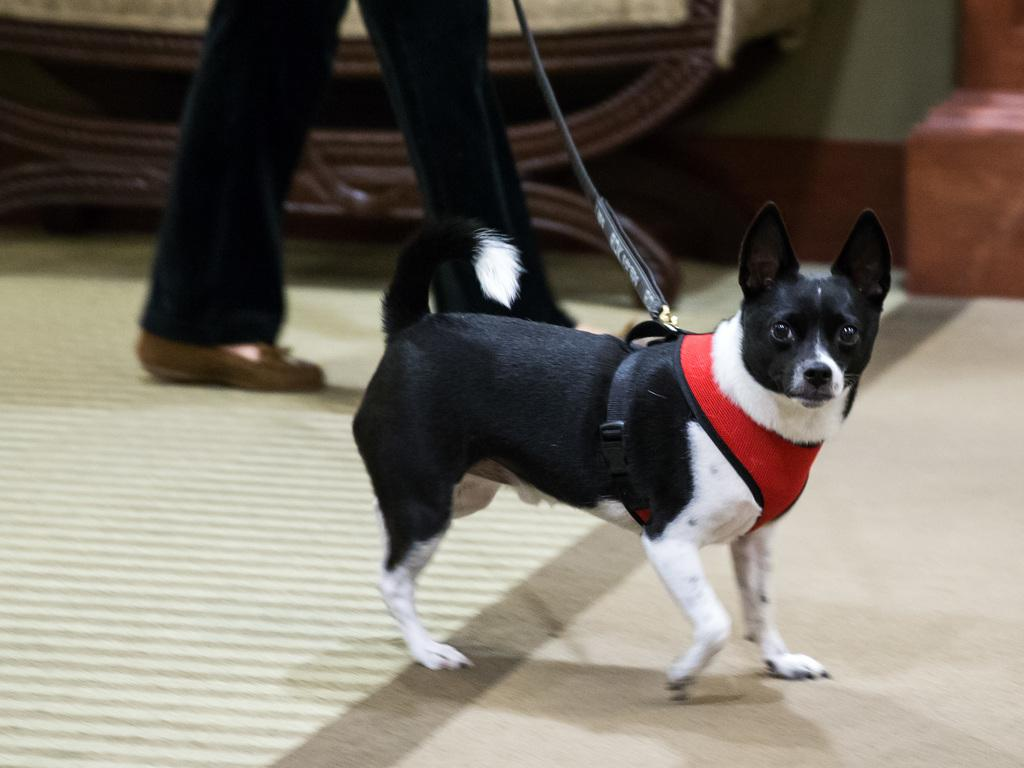What type of animal is in the image? There is an animal in the image, but the specific type cannot be determined from the provided facts. Can you describe the person in the image? There is a person in the image, but no specific details about their appearance or actions are given. What can be seen in the background of the image? There are objects in the background of the image, but no specific details about them are provided. What color is the kite that the person is holding in the image? There is no kite present in the image, so it cannot be determined what color it might be. 